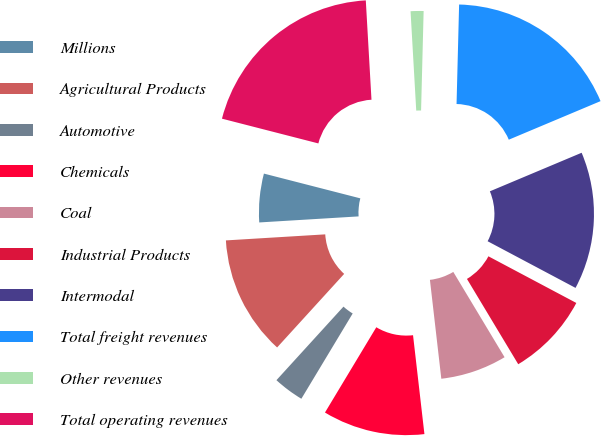<chart> <loc_0><loc_0><loc_500><loc_500><pie_chart><fcel>Millions<fcel>Agricultural Products<fcel>Automotive<fcel>Chemicals<fcel>Coal<fcel>Industrial Products<fcel>Intermodal<fcel>Total freight revenues<fcel>Other revenues<fcel>Total operating revenues<nl><fcel>4.97%<fcel>12.27%<fcel>3.14%<fcel>10.45%<fcel>6.79%<fcel>8.62%<fcel>14.1%<fcel>18.26%<fcel>1.32%<fcel>20.09%<nl></chart> 